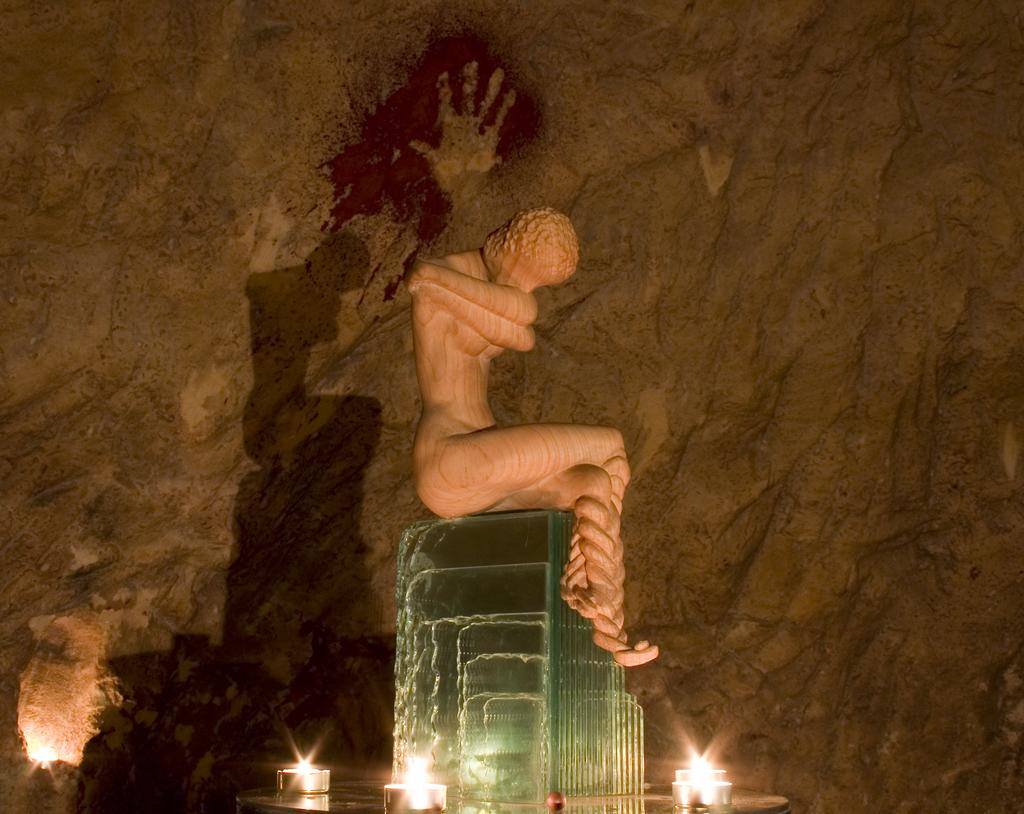What is the main subject in the image? There is a statue in the image. What is the statue sitting on? The statue is sitting on a hard object. What can be seen in the background of the image? The background of the image consists of rocks. What type of crayon is the statue holding in the image? There is no crayon present in the image; the statue is not holding anything. 